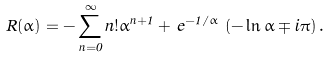<formula> <loc_0><loc_0><loc_500><loc_500>R ( \alpha ) = - \sum _ { n = 0 } ^ { \infty } n ! \alpha ^ { n + 1 } + \, e ^ { - 1 / \alpha } \, \left ( - \ln \alpha \mp i \pi \right ) .</formula> 